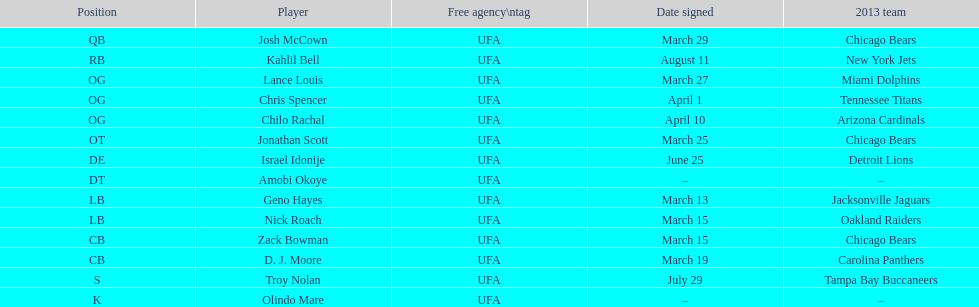The first name of him/her corresponds to a country's name. Israel Idonije. 